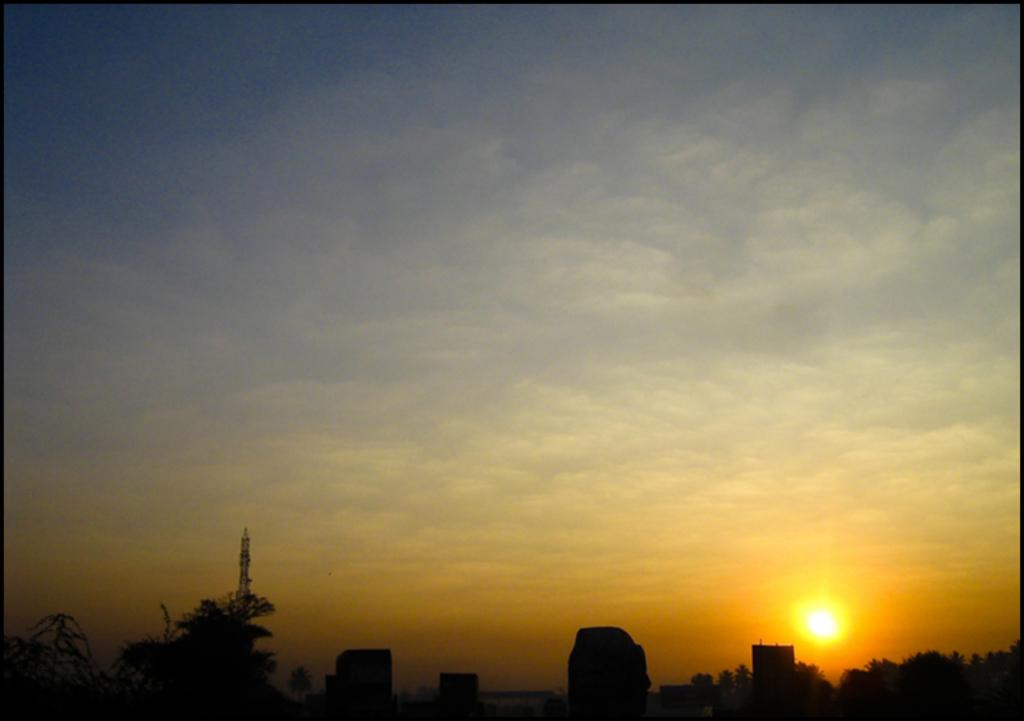Where was the image taken? The image was taken outdoors. What can be seen in the sky in the image? There is a sky with clouds in the image, and the sun is visible. What type of structures are present in the image? There are buildings and a tower in the image. What type of natural elements are present in the image? Trees, plants, and clouds are present in the image. What verse from a song can be heard in the image? There is no sound or audio in the image, so it is not possible to determine any verses from a song. 